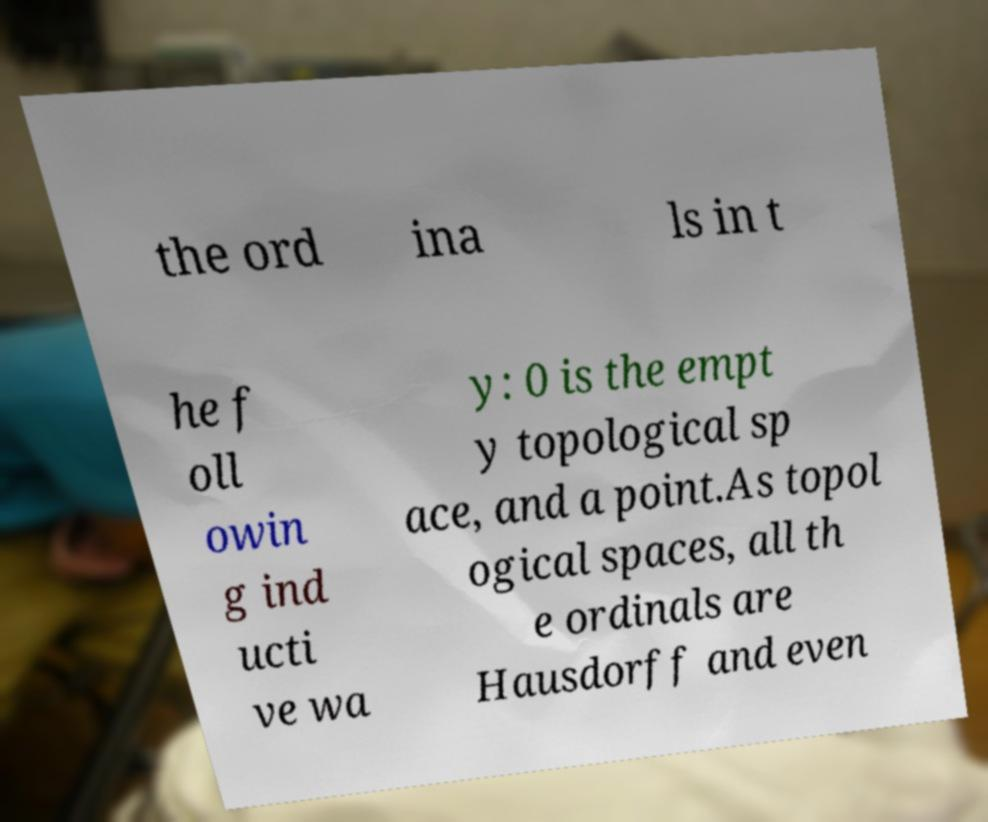For documentation purposes, I need the text within this image transcribed. Could you provide that? the ord ina ls in t he f oll owin g ind ucti ve wa y: 0 is the empt y topological sp ace, and a point.As topol ogical spaces, all th e ordinals are Hausdorff and even 